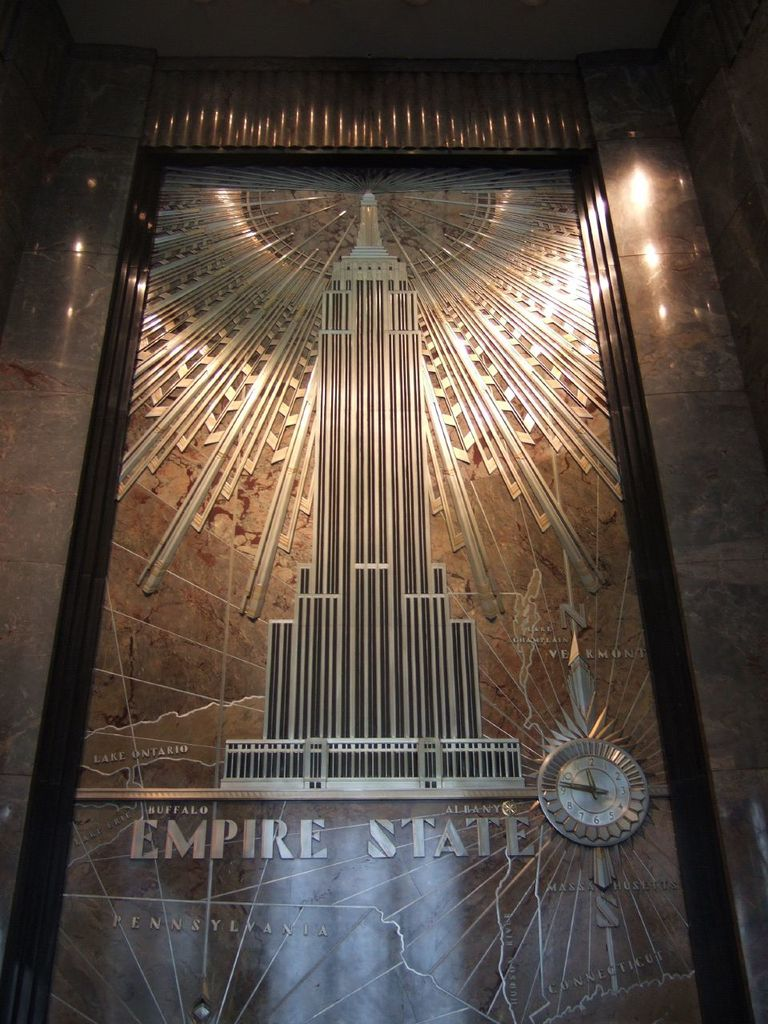Provide a one-sentence caption for the provided image. The image displays a stunning art deco metal relief of the Empire State Building, intricately designed and integrated within the architectural elements of a lobby, complemented by a map of New York state and a clock. 